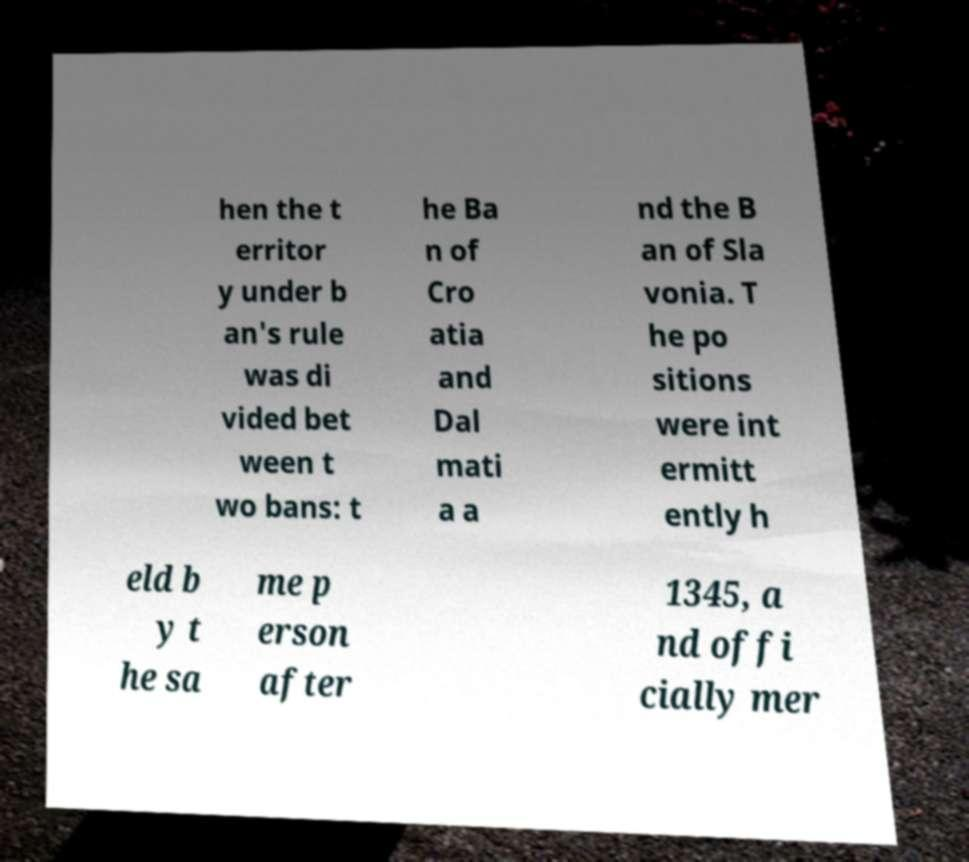Please identify and transcribe the text found in this image. hen the t erritor y under b an's rule was di vided bet ween t wo bans: t he Ba n of Cro atia and Dal mati a a nd the B an of Sla vonia. T he po sitions were int ermitt ently h eld b y t he sa me p erson after 1345, a nd offi cially mer 